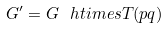Convert formula to latex. <formula><loc_0><loc_0><loc_500><loc_500>G ^ { \prime } = G \ h t i m e s { T } ( p q )</formula> 